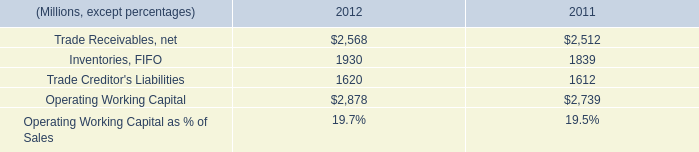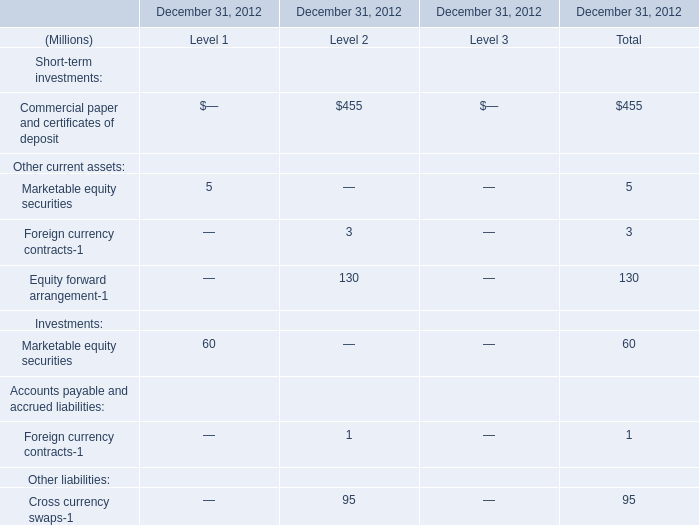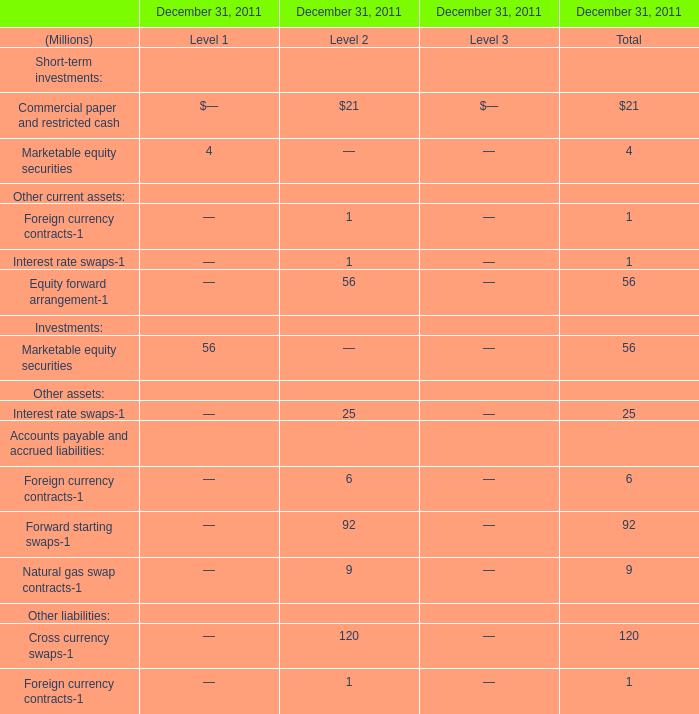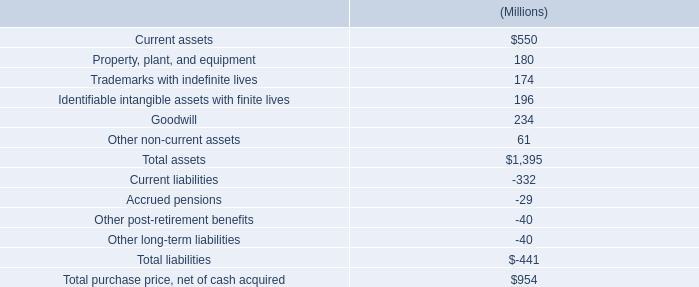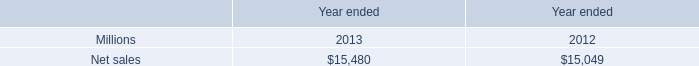what was the difference in millions of capital spending related to business acquisitions from 2010 to 2011? 
Computations: (56 - 34)
Answer: 22.0. 